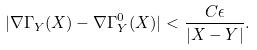<formula> <loc_0><loc_0><loc_500><loc_500>| \nabla \Gamma _ { Y } ( X ) - \nabla \Gamma _ { Y } ^ { 0 } ( X ) | < \frac { C \epsilon } { | X - Y | } .</formula> 